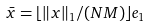Convert formula to latex. <formula><loc_0><loc_0><loc_500><loc_500>\bar { x } = \lfloor \| x \| _ { 1 } / ( N M ) \rfloor e _ { 1 }</formula> 